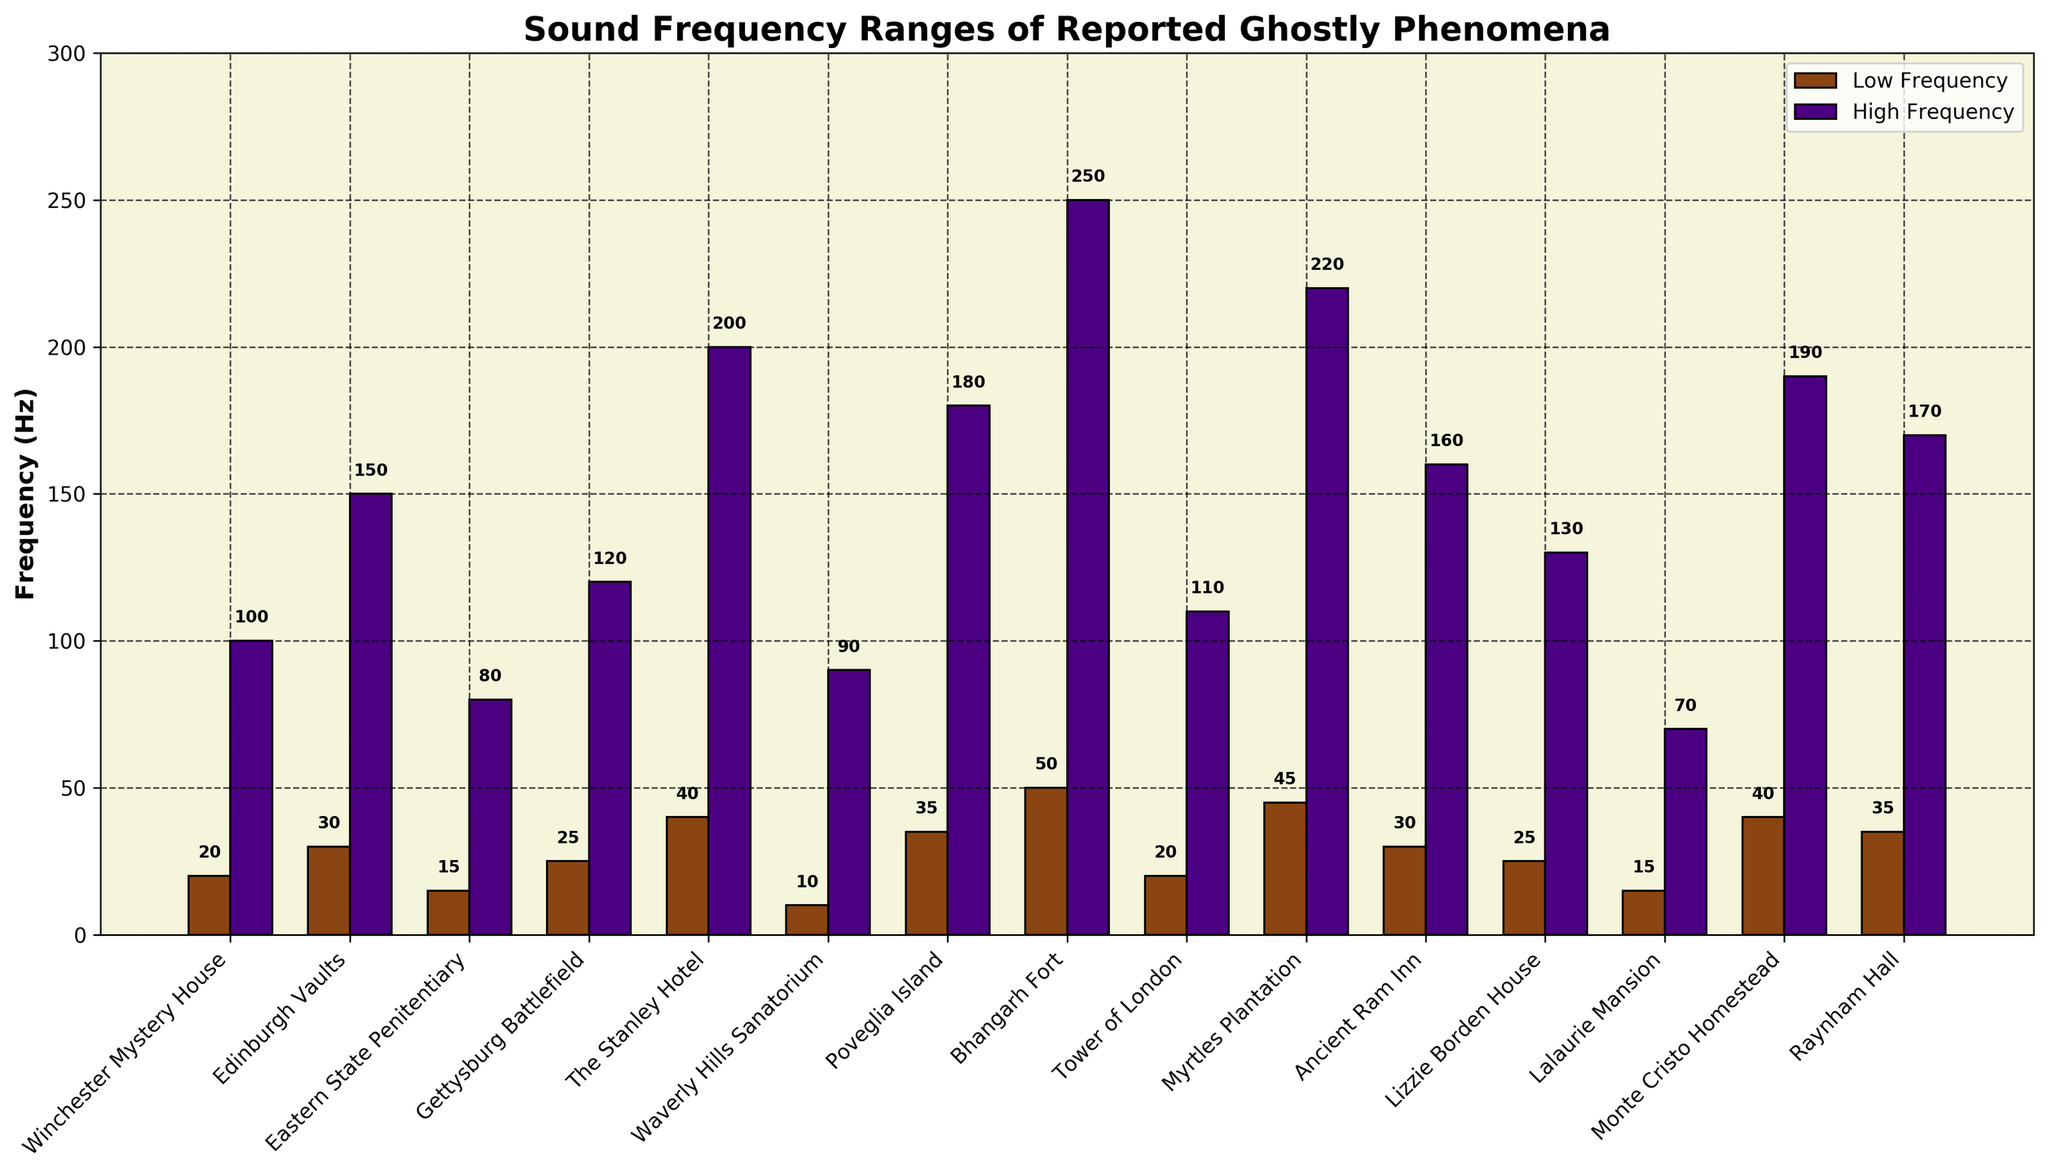Which location has the highest low frequency range? Look at the bar plot for the "Low Frequency" bars. The location with the highest low frequency bar is Bhangarh Fort.
Answer: Bhangarh Fort Which location has the smallest difference between low and high frequency ranges? Calculate the difference between high and low frequencies for each location and compare them. The smallest difference is found for Lalaurie Mansion (70 - 15 = 55).
Answer: Lalaurie Mansion What is the average high frequency range across all locations? Sum the high frequency values and divide by the number of locations: (100 + 150 + 80 + 120 + 200 + 90 + 180 + 250 + 110 + 220 + 160 + 130 + 70 + 190 + 170) / 15 = 163.33.
Answer: 163.33 Which location has a high frequency range greater than 200 Hz? Look at the bar plot for the "High Frequency" bars and identify any bar greater than 200. The locations that meet this criterion are Bhangarh Fort (250 Hz) and Myrtles Plantation (220 Hz).
Answer: Bhangarh Fort, Myrtles Plantation What is the median low frequency range of all locations? Arrange the low frequency values in numerical order and find the middle value: 10, 15, 15, 20, 20, 25, 25, 30, 30, 35, 35, 40, 40, 45, 50. The median value is 30 Hz.
Answer: 30 Which site has a low frequency around 20 Hz and a high frequency around 100 Hz? Check the bars closest to these values. Winchester Mystery House has low frequency of 20 Hz and high frequency of 100 Hz.
Answer: Winchester Mystery House Compare the low frequency ranges of Tower of London and Gettysburg Battlefield. Which one is higher? Compare their low frequency values directly from the plot. Tower of London has 20 Hz, Gettysburg Battlefield has 25 Hz. Gettysburg Battlefield is higher.
Answer: Gettysburg Battlefield Which location has the greatest range between its low frequency and high frequency? Calculate the ranges and find the maximum: Bhangarh Fort (250 - 50 = 200).
Answer: Bhangarh Fort What is the difference in high frequency range between The Stanley Hotel and Poveglia Island? Subtract the high frequency of Poveglia Island from that of The Stanley Hotel: 200 - 180 = 20.
Answer: 20 Identify the locations where both low and high frequency ranges are lower than 100 Hz. Check the plot for locations where both bars are below 100. The locations are Eastern State Penitentiary (15, 80) and Lalaurie Mansion (15, 70).
Answer: Eastern State Penitentiary, Lalaurie Mansion 